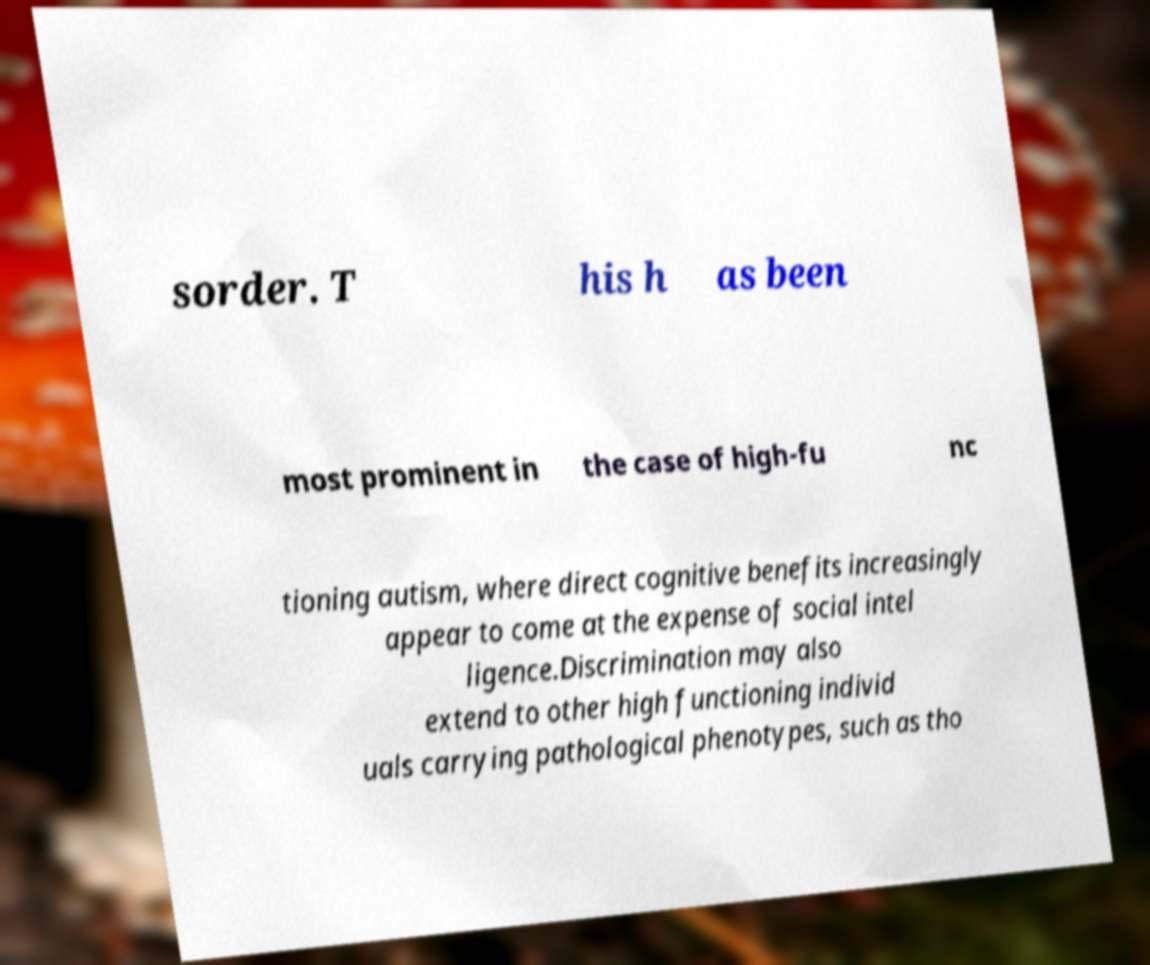Please read and relay the text visible in this image. What does it say? sorder. T his h as been most prominent in the case of high-fu nc tioning autism, where direct cognitive benefits increasingly appear to come at the expense of social intel ligence.Discrimination may also extend to other high functioning individ uals carrying pathological phenotypes, such as tho 